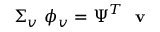Convert formula to latex. <formula><loc_0><loc_0><loc_500><loc_500>\Sigma _ { v } \ \phi _ { v } = \Psi ^ { T } \ v</formula> 